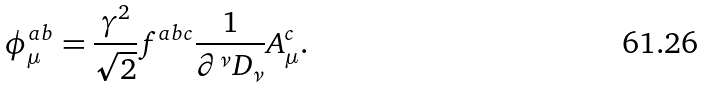<formula> <loc_0><loc_0><loc_500><loc_500>\phi ^ { a b } _ { \mu } = \frac { \gamma ^ { 2 } } { \sqrt { 2 } } f ^ { a b c } \frac { 1 } { \partial ^ { \nu } D _ { \nu } } A ^ { c } _ { \mu } .</formula> 